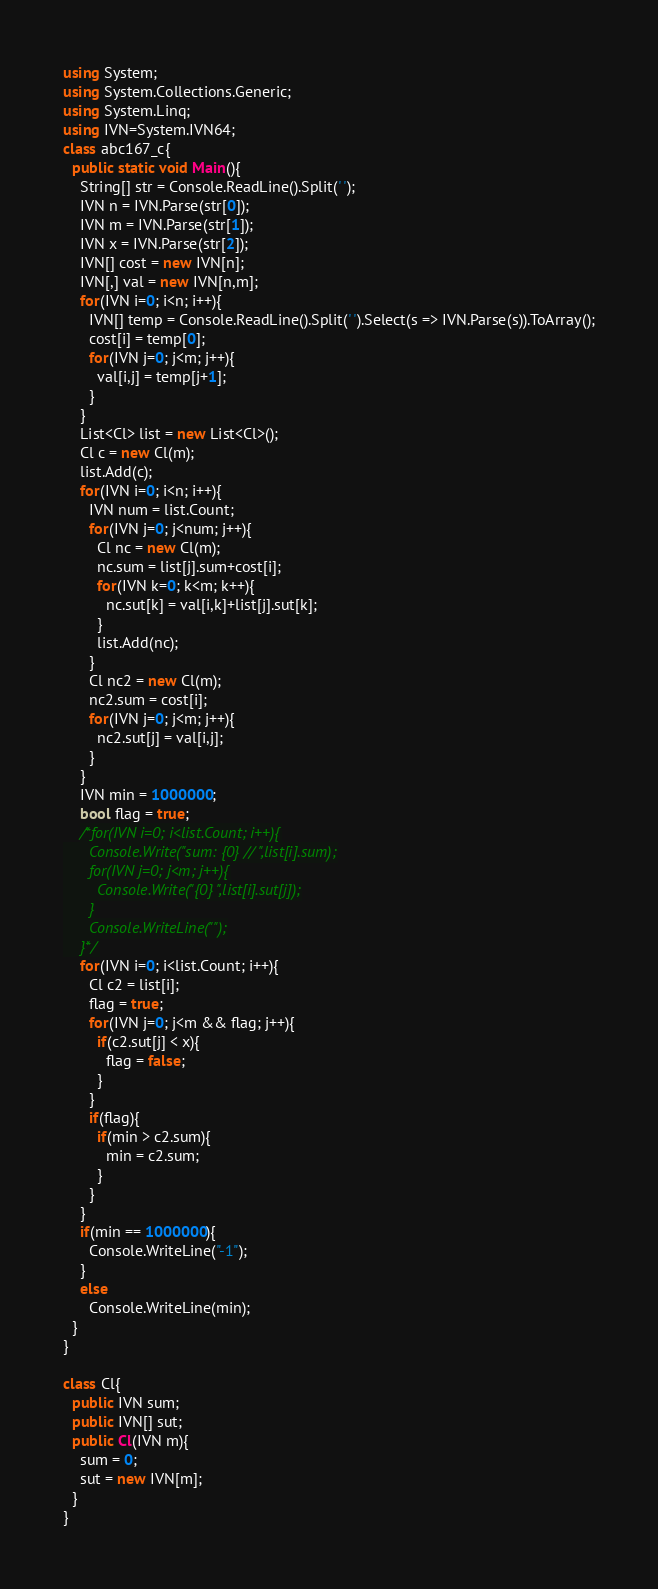Convert code to text. <code><loc_0><loc_0><loc_500><loc_500><_C#_>using System;
using System.Collections.Generic;
using System.Linq;
using IVN=System.IVN64;
class abc167_c{
  public static void Main(){
    String[] str = Console.ReadLine().Split(' ');
    IVN n = IVN.Parse(str[0]);
    IVN m = IVN.Parse(str[1]);
    IVN x = IVN.Parse(str[2]);
    IVN[] cost = new IVN[n];
    IVN[,] val = new IVN[n,m];
    for(IVN i=0; i<n; i++){
      IVN[] temp = Console.ReadLine().Split(' ').Select(s => IVN.Parse(s)).ToArray();
      cost[i] = temp[0];
      for(IVN j=0; j<m; j++){
        val[i,j] = temp[j+1];
      }
    }
    List<Cl> list = new List<Cl>();
    Cl c = new Cl(m);
    list.Add(c);
    for(IVN i=0; i<n; i++){
      IVN num = list.Count;
      for(IVN j=0; j<num; j++){
        Cl nc = new Cl(m);
        nc.sum = list[j].sum+cost[i];
        for(IVN k=0; k<m; k++){
          nc.sut[k] = val[i,k]+list[j].sut[k];
        }
        list.Add(nc);
      }
      Cl nc2 = new Cl(m);
      nc2.sum = cost[i];
      for(IVN j=0; j<m; j++){
        nc2.sut[j] = val[i,j];
      }
    }
    IVN min = 1000000;
    bool flag = true;
    /*for(IVN i=0; i<list.Count; i++){
      Console.Write("sum: {0} // ",list[i].sum);
      for(IVN j=0; j<m; j++){
        Console.Write("{0} ",list[i].sut[j]);
      }
      Console.WriteLine("");
    }*/
    for(IVN i=0; i<list.Count; i++){
      Cl c2 = list[i];
      flag = true;
      for(IVN j=0; j<m && flag; j++){
        if(c2.sut[j] < x){
          flag = false;
        }
      }
      if(flag){
        if(min > c2.sum){
          min = c2.sum;
        }
      }
    }
    if(min == 1000000){
      Console.WriteLine("-1");
    }
    else
      Console.WriteLine(min);
  }
}

class Cl{
  public IVN sum;
  public IVN[] sut;
  public Cl(IVN m){
    sum = 0;
    sut = new IVN[m];
  }
}
</code> 